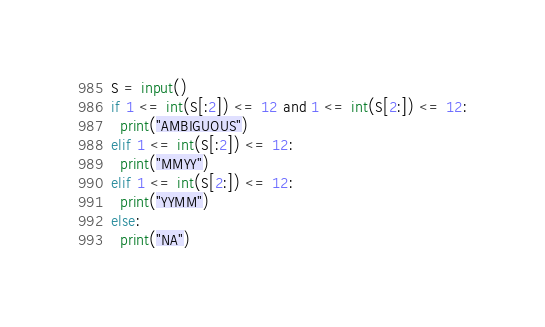Convert code to text. <code><loc_0><loc_0><loc_500><loc_500><_Python_>S = input()
if 1 <= int(S[:2]) <= 12 and 1 <= int(S[2:]) <= 12:
  print("AMBIGUOUS")
elif 1 <= int(S[:2]) <= 12:
  print("MMYY")
elif 1 <= int(S[2:]) <= 12:
  print("YYMM")
else:
  print("NA")</code> 